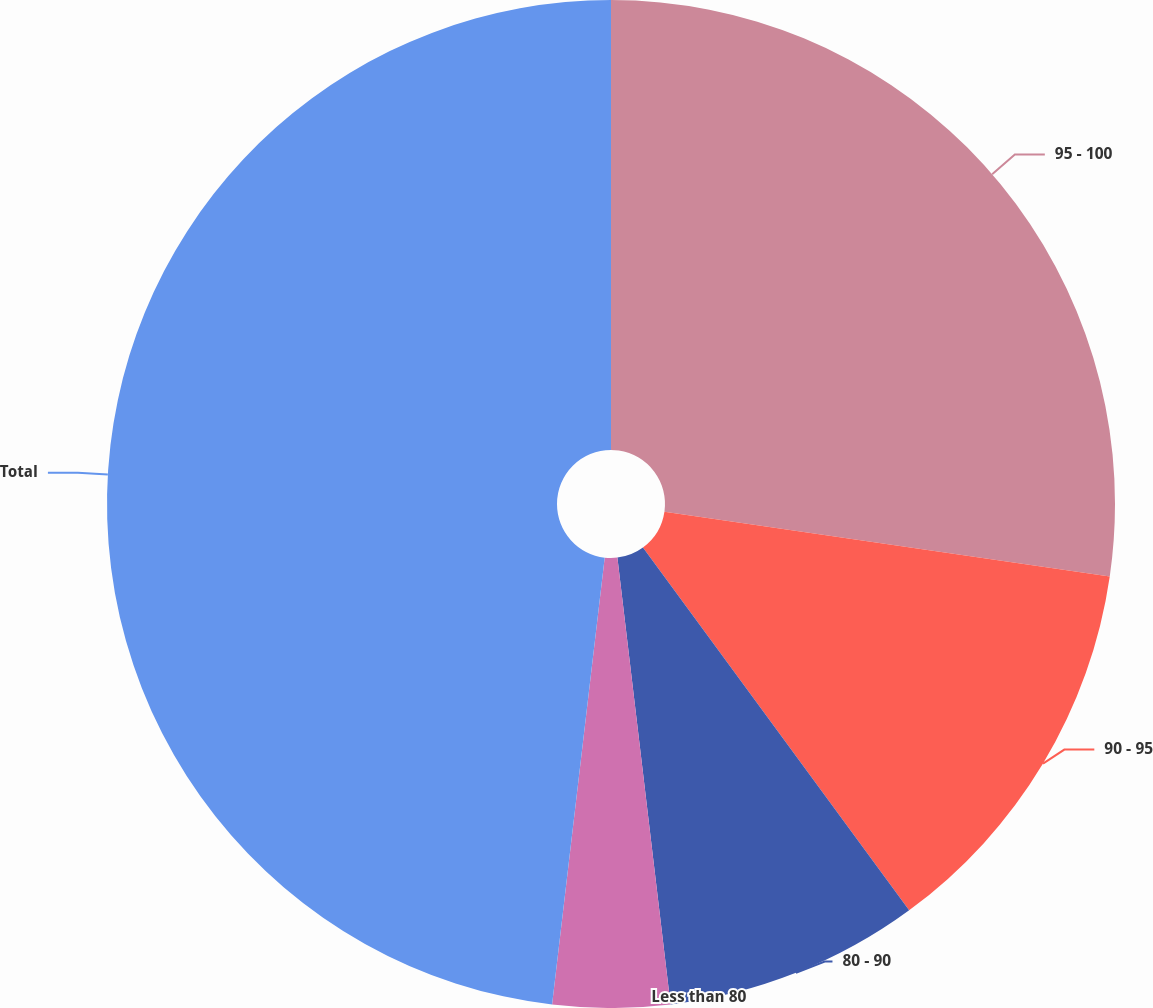Convert chart. <chart><loc_0><loc_0><loc_500><loc_500><pie_chart><fcel>95 - 100<fcel>90 - 95<fcel>80 - 90<fcel>Less than 80<fcel>Total<nl><fcel>27.3%<fcel>12.63%<fcel>8.19%<fcel>3.75%<fcel>48.14%<nl></chart> 